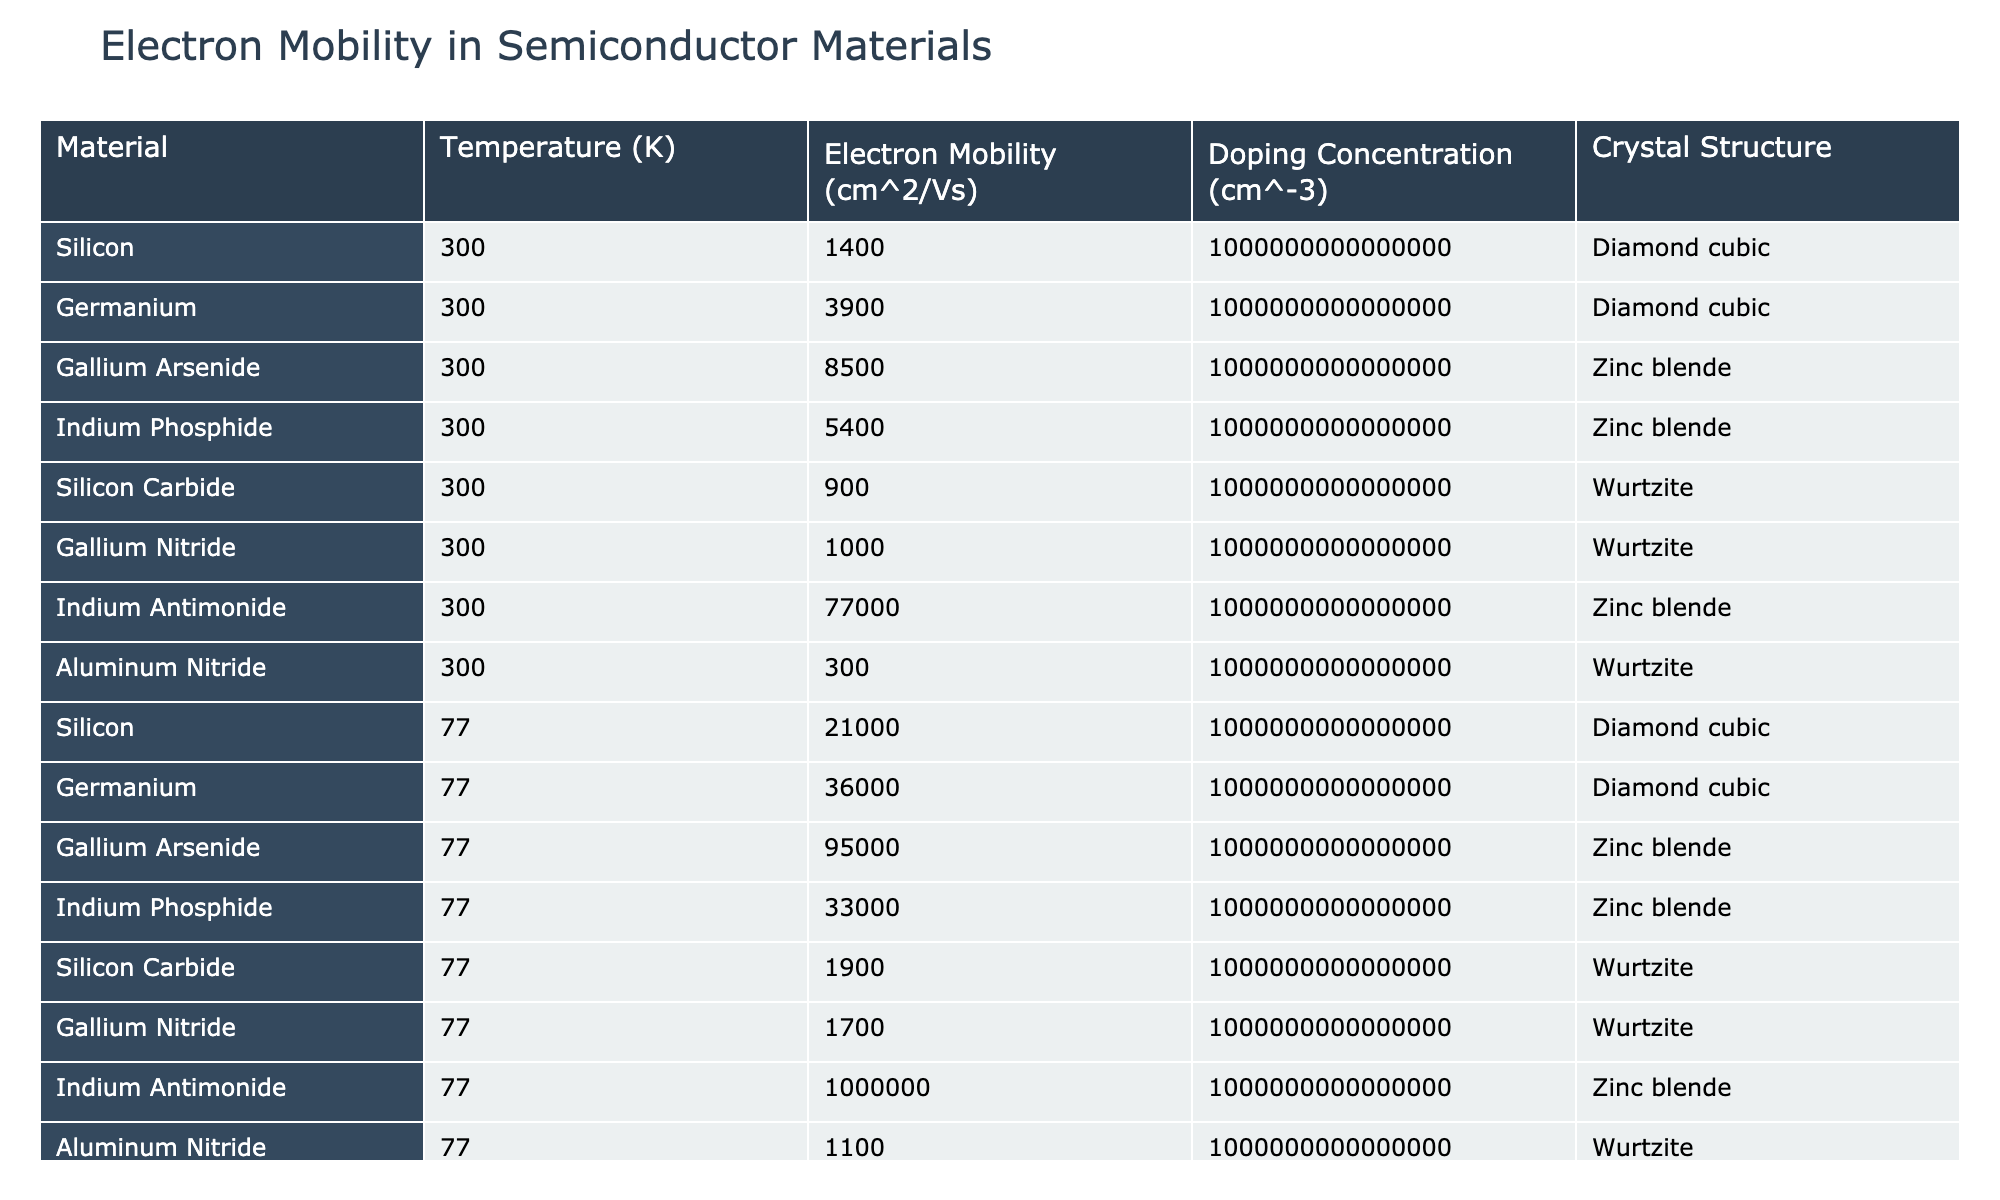What is the electron mobility of Gallium Arsenide at 300 K? Referring to the table, the value for Gallium Arsenide at 300 K is listed as 8500 cm²/Vs.
Answer: 8500 cm²/Vs Which material has the highest electron mobility at 77 K? The maximum electron mobility at 77 K is found by comparing the values in that row of the table. Indium Antimonide has the highest mobility at 1,000,000 cm²/Vs.
Answer: 1,000,000 cm²/Vs What is the doping concentration for all materials listed in the table? Looking at the doping concentration column, it shows a constant value of 1e15 cm⁻³ for all materials listed, indicating that they are all doped at the same concentration.
Answer: 1e15 cm⁻³ What is the difference in electron mobility between Silicon at 300 K and Silicon at 77 K? From the table, Silicon at 300 K has an electron mobility of 1400 cm²/Vs, while at 77 K it has 21,000 cm²/Vs. The difference is calculated as 21,000 - 1400 = 19,600 cm²/Vs.
Answer: 19,600 cm²/Vs Is the electron mobility of Aluminum Nitride at 300 K greater than that of Silicon Carbide at the same temperature? According to the table, Aluminum Nitride has a mobility of 300 cm²/Vs, while Silicon Carbide has 900 cm²/Vs. Since 300 < 900, the statement is false.
Answer: No What is the average electron mobility of all materials measured at 300 K? To find the average, sum the electron mobilities at 300 K: (1400 + 3900 + 8500 + 5400 + 900 + 1000 + 77000 + 300) = 92000, and divide by the number of materials (8) to get 92000 / 8 = 11500 cm²/Vs.
Answer: 11500 cm²/Vs Which crystal structure corresponds to the material with the lowest electron mobility at 77 K? The lowest electron mobility at 77 K belongs to Aluminum Nitride, which has a mobility of 1100 cm²/Vs and is in the Wurtzite structure.
Answer: Wurtzite Are materials with the Diamond cubic crystal structure generally exhibiting higher electron mobility at room temperature compared to those with Wurtzite? Evaluating the mobilities for Diamond cubic (Silicon - 1400, Germanium - 3900) and Wurtzite (Silicon Carbide - 900, Gallium Nitride - 1000) at 300 K, the Diamond cubic values sum to 5300 cm²/Vs while Wurtzite sums to 1900 cm²/Vs. Thus, the statement is true.
Answer: Yes What is the relationship between temperature and electron mobility for Silicon and Germanium in this data? Examining the table shows that in both cases, reducing the temperature from 300 K to 77 K leads to a significant increase in electron mobility (Silicon increases from 1400 to 21000, and Germanium from 3900 to 36000). This indicates that lower temperatures promote higher electron mobility for these materials.
Answer: Increases with lower temperature 